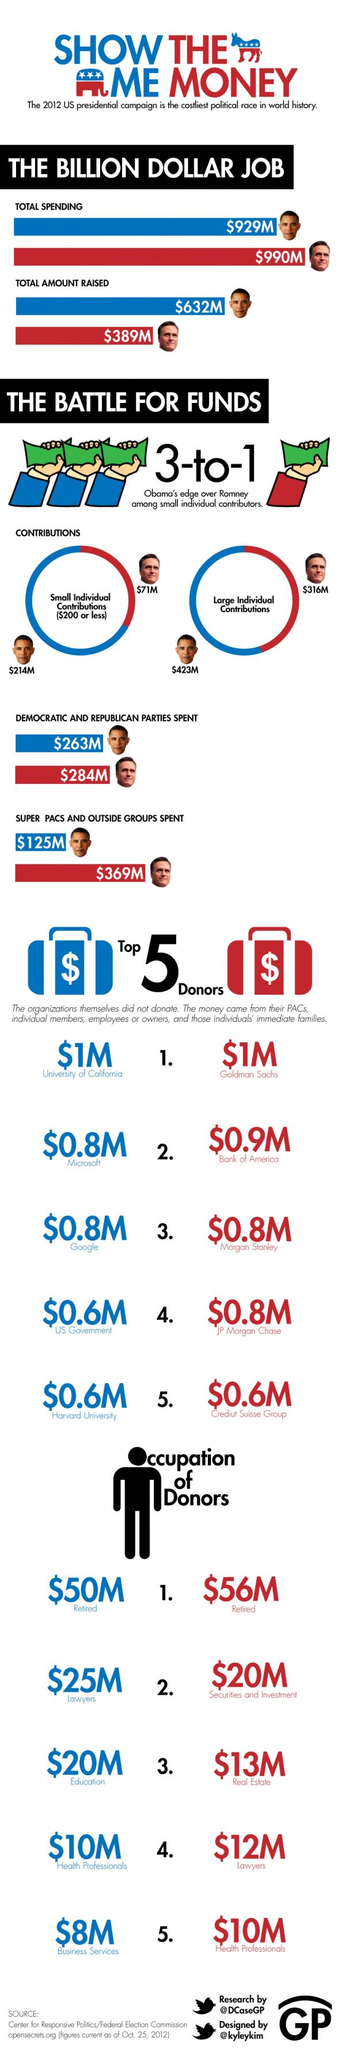Mention a couple of crucial points in this snapshot. The Republican party spent $284 million during the 2012 US presidential campaign. During the 2012 US presidential campaign, the Democratic Party received a total of $125 million in spending from super PACs and other outside groups. During the 2012 US presidential campaign, the Democratic party received a total of $0.8 million in donations from Microsoft. The Bank of America donated $0.9 million to the Republican party during the 2012 US presidential campaign. In the 2012 presidential campaign, the total spending on the Barack Obama campaign was $929 million. 